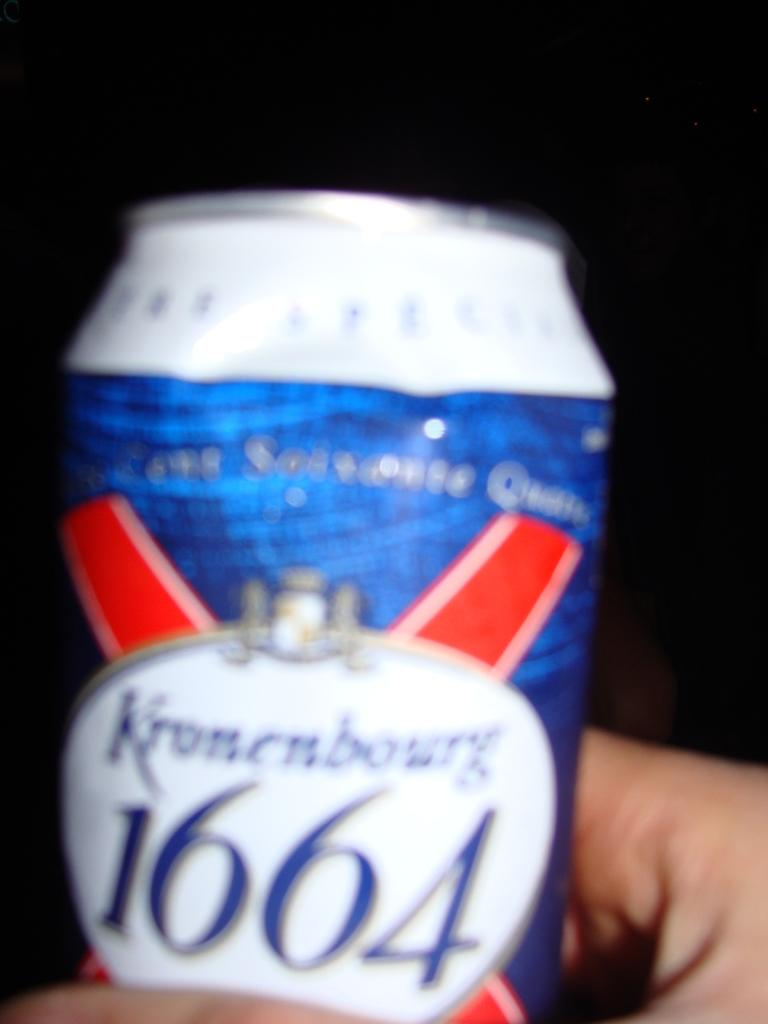<image>
Offer a succinct explanation of the picture presented. A blue and white can of Kroncubourg 1664 beer. 